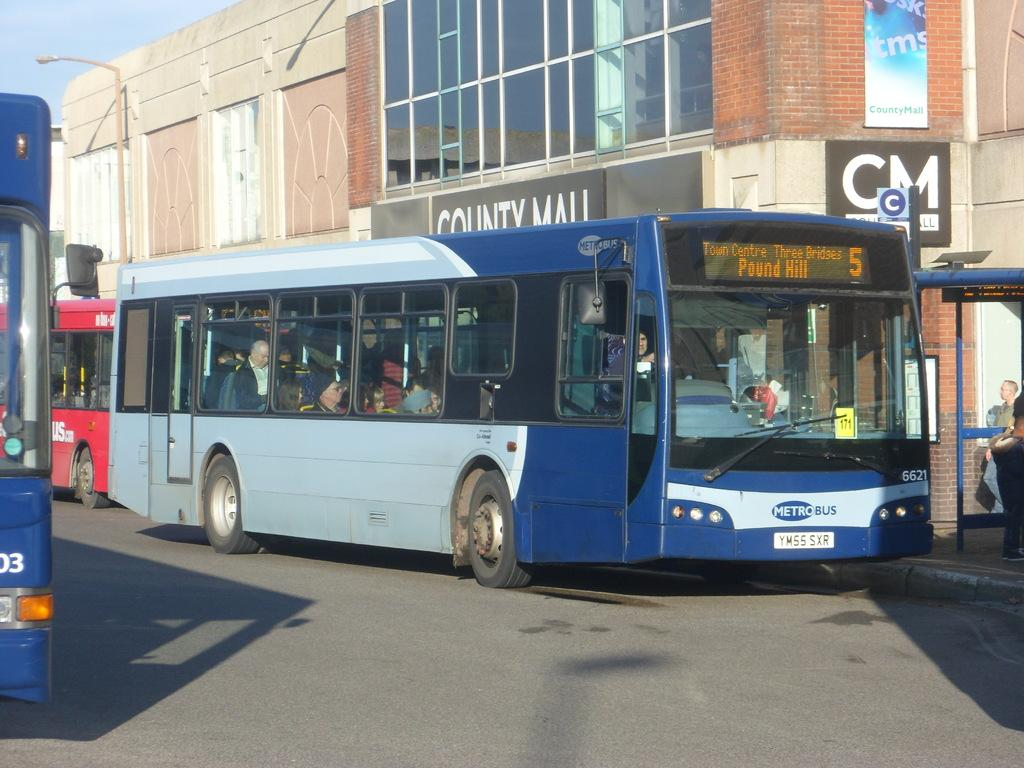<image>
Write a terse but informative summary of the picture. A city bus that is headed to Pound Hill. 